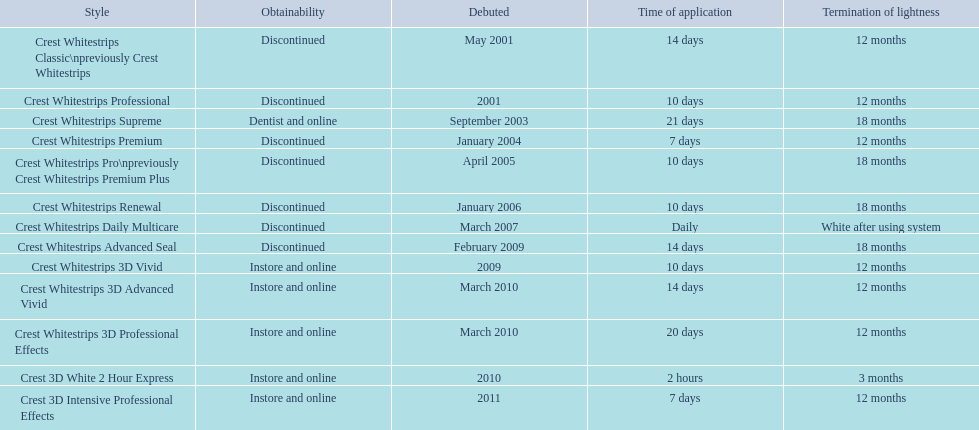What products are listed? Crest Whitestrips Classic\npreviously Crest Whitestrips, Crest Whitestrips Professional, Crest Whitestrips Supreme, Crest Whitestrips Premium, Crest Whitestrips Pro\npreviously Crest Whitestrips Premium Plus, Crest Whitestrips Renewal, Crest Whitestrips Daily Multicare, Crest Whitestrips Advanced Seal, Crest Whitestrips 3D Vivid, Crest Whitestrips 3D Advanced Vivid, Crest Whitestrips 3D Professional Effects, Crest 3D White 2 Hour Express, Crest 3D Intensive Professional Effects. Of these, which was were introduced in march, 2010? Crest Whitestrips 3D Advanced Vivid, Crest Whitestrips 3D Professional Effects. Of these, which were not 3d advanced vivid? Crest Whitestrips 3D Professional Effects. 